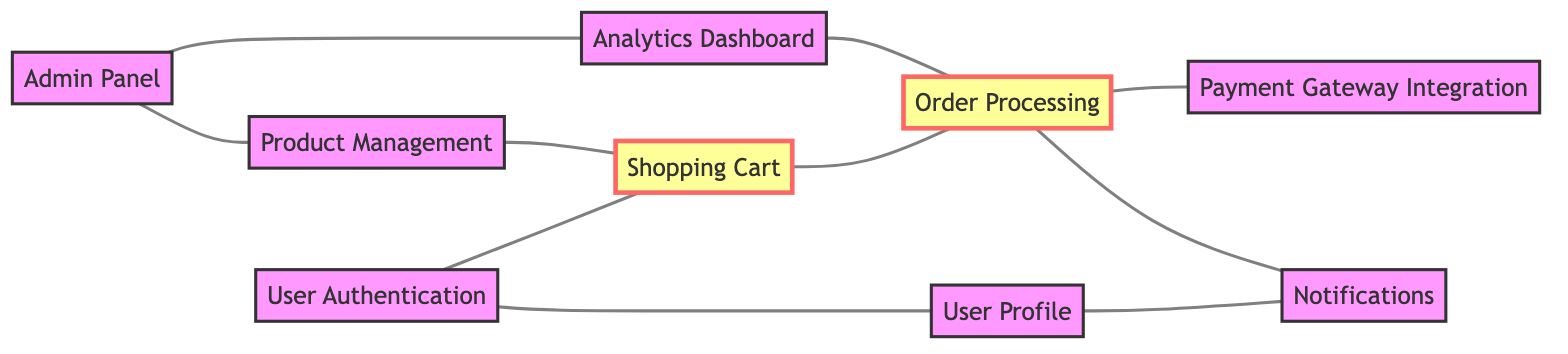What is the total number of features depicted in the diagram? The diagram lists a specific set of features within the 'elements' section. Counting each feature in the 'features' array yields a total of nine unique features: User Authentication, Product Management, Shopping Cart, Order Processing, Payment Gateway Integration, User Profile, Notifications, Analytics Dashboard, and Admin Panel.
Answer: Nine How many dependencies are there between the features? By reviewing the 'dependencies' array within the data, I can count each dependency listed between features. There are ten dependencies mentioned.
Answer: Ten Which feature depends directly on User Authentication? Looking at the edges connected to the 'User Authentication' node, I see it connects directly to 'User Profile' and 'Shopping Cart'. This indicates that both features depend on User Authentication.
Answer: User Profile, Shopping Cart What feature is dependent on both Shopping Cart and Order Processing? To analyze this, I start by examining the edges linked to 'Shopping Cart' and 'Order Processing'. The Shopping Cart connects with 'Order Processing', which signifies that Order Processing can be influenced by the state of the Shopping Cart. However, no feature directly depends on both, as they are linked sequentially, not co-dependently.
Answer: None Which feature has the highest number of dependencies? I analyze each feature and count the outgoing edges to other features. User Authentication has two, Product Management has one, Shopping Cart has one, Order Processing has three, Payment Gateway Integration has zero, User Profile has one, Notifications has zero, Analytics Dashboard has one, and Admin Panel has two. Thus, Order Processing holds the maximum with three dependencies.
Answer: Order Processing Is User Profile dependent on any other feature? To determine this, I can observe the edges linked to 'User Profile'. It has one direct dependency leading to 'Notifications', confirming that it is indeed dependent on another feature.
Answer: Yes How many features lead to Order Processing? Looking at the edges pointed towards the 'Order Processing' node, it is influenced directly by 'Shopping Cart' and 'Analytics Dashboard'. Thus, I can count two directed edges or dependencies leading to Order Processing.
Answer: Two Which feature is connected to the Admin Panel? I will identify the edges originating from the 'Admin Panel'. The Admin Panel has direct ties to both 'Product Management' and 'Analytics Dashboard'. Therefore, both features are connected to the Admin Panel.
Answer: Product Management, Analytics Dashboard How many features do not connect to Notifications? By reviewing the edges connected to the Notifications node, I notice it is influenced directly by 'User Profile' and 'Order Processing', meaning only those features link to Notifications. The features that do not connect to it include User Authentication, Product Management, Shopping Cart, Payment Gateway Integration, and Admin Panel. Counting these provides a total of five.
Answer: Five 